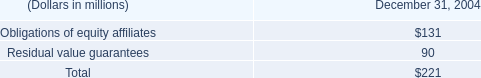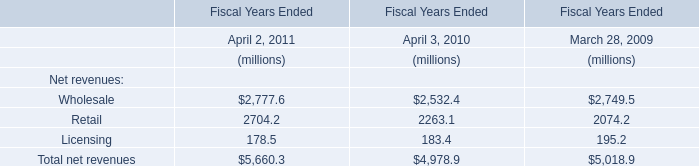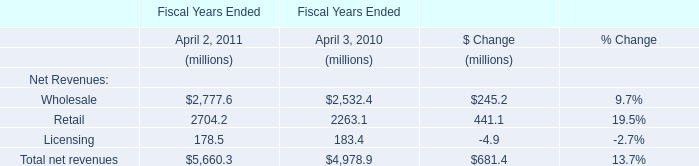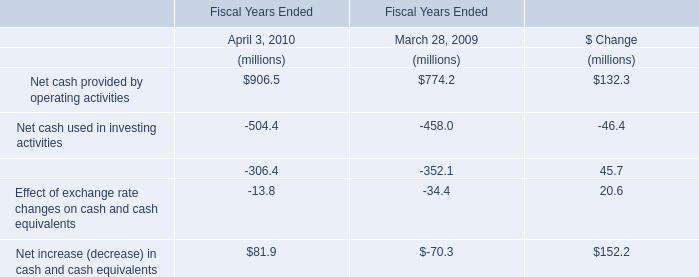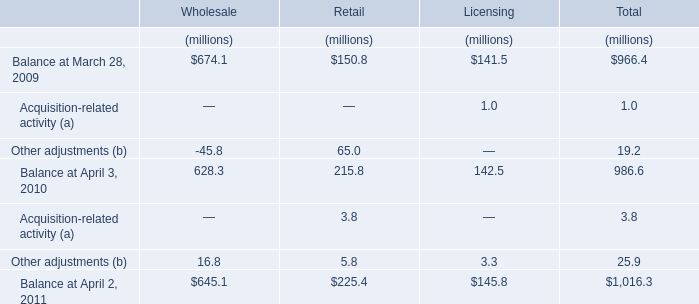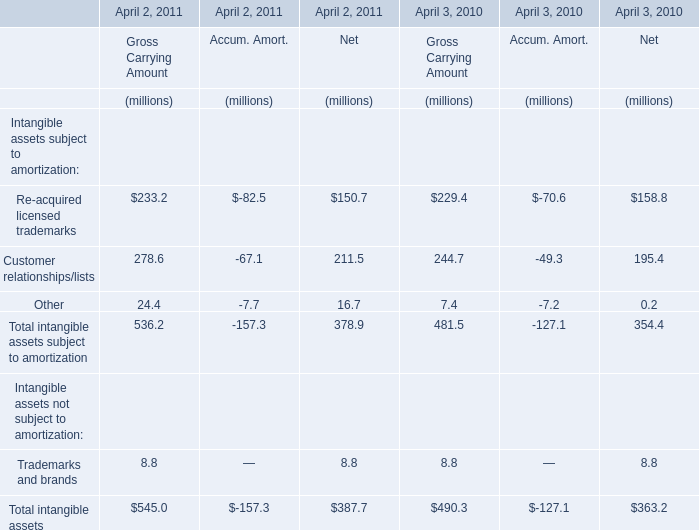What is the percentage of Re-acquired licensed trademarks for Gross Carrying Amount in relation to the total in 2011? 
Computations: (233.2 / 545)
Answer: 0.42789. 